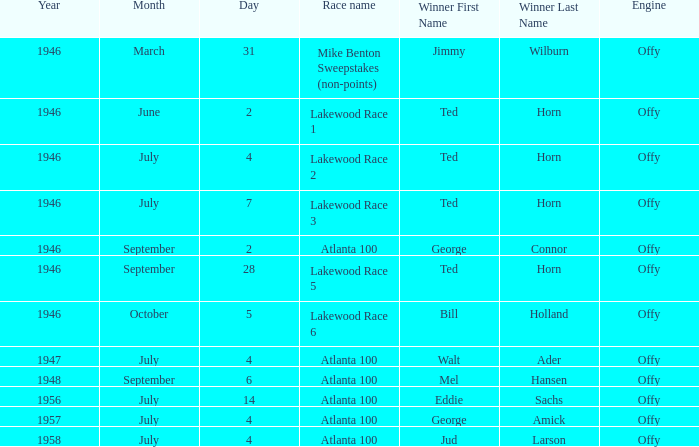Jud Larson who which race after 1956? Atlanta 100. 